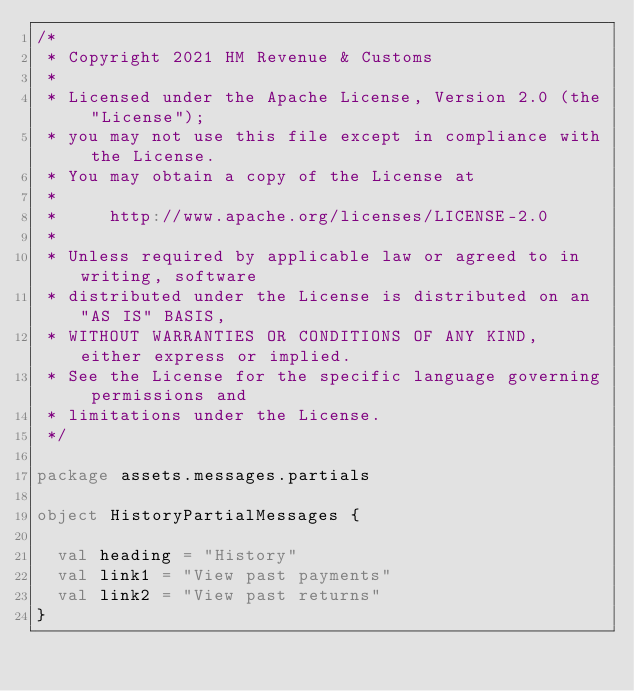Convert code to text. <code><loc_0><loc_0><loc_500><loc_500><_Scala_>/*
 * Copyright 2021 HM Revenue & Customs
 *
 * Licensed under the Apache License, Version 2.0 (the "License");
 * you may not use this file except in compliance with the License.
 * You may obtain a copy of the License at
 *
 *     http://www.apache.org/licenses/LICENSE-2.0
 *
 * Unless required by applicable law or agreed to in writing, software
 * distributed under the License is distributed on an "AS IS" BASIS,
 * WITHOUT WARRANTIES OR CONDITIONS OF ANY KIND, either express or implied.
 * See the License for the specific language governing permissions and
 * limitations under the License.
 */

package assets.messages.partials

object HistoryPartialMessages {

  val heading = "History"
  val link1 = "View past payments"
  val link2 = "View past returns"
}
</code> 